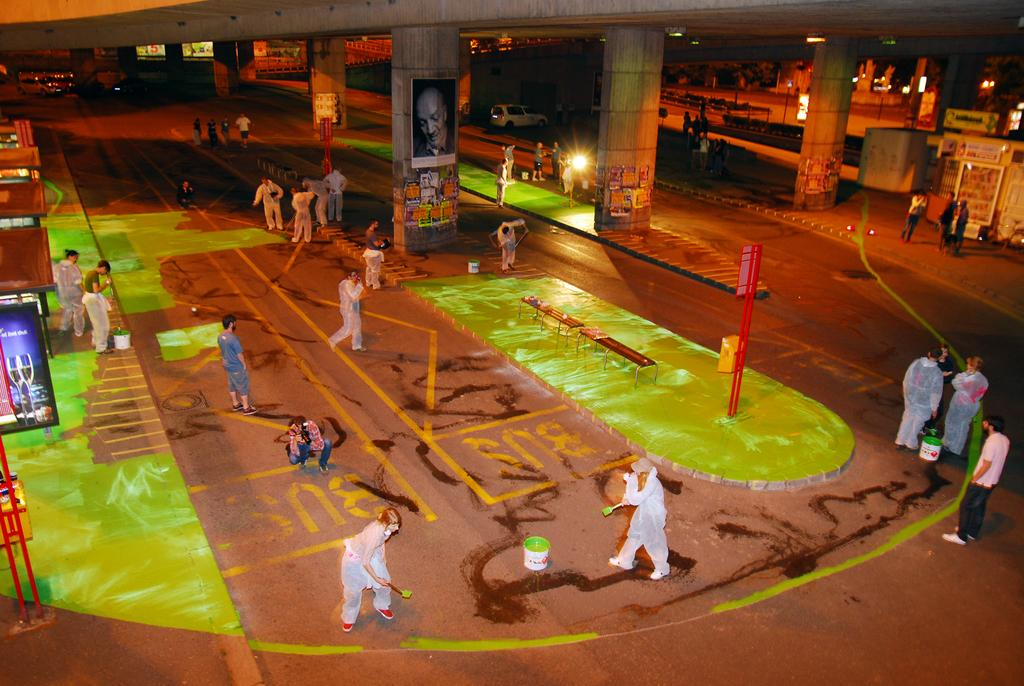What can be seen on the road in the image? There is a group of people on the road in the image. What objects are present in the image besides the people? There are buckets, benches, poles, boards, hoardings, pillars, and vehicles in the image. What can be seen in the background of the image? There are buildings and lights in the background of the image. What type of industry is depicted in the image? There is no industry depicted in the image; it features a group of people on the road, various objects, and a background with buildings and lights. What kind of vessel can be seen navigating the waters in the image? There are no vessels or bodies of water present in the image. 